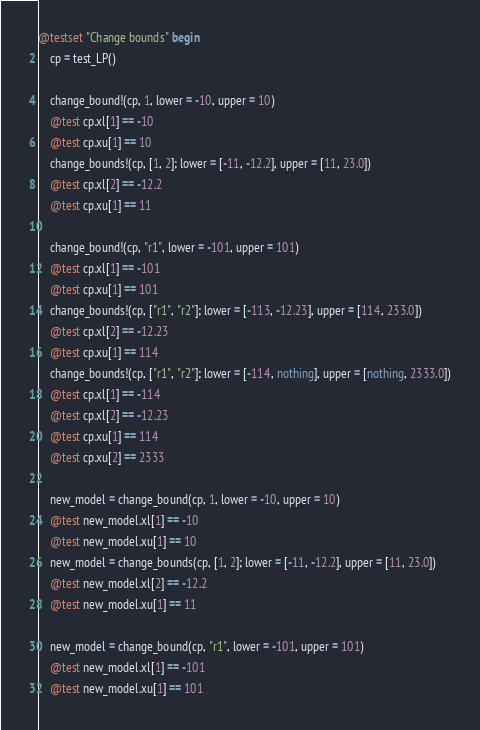Convert code to text. <code><loc_0><loc_0><loc_500><loc_500><_Julia_>@testset "Change bounds" begin
    cp = test_LP()

    change_bound!(cp, 1, lower = -10, upper = 10)
    @test cp.xl[1] == -10
    @test cp.xu[1] == 10
    change_bounds!(cp, [1, 2]; lower = [-11, -12.2], upper = [11, 23.0])
    @test cp.xl[2] == -12.2
    @test cp.xu[1] == 11

    change_bound!(cp, "r1", lower = -101, upper = 101)
    @test cp.xl[1] == -101
    @test cp.xu[1] == 101
    change_bounds!(cp, ["r1", "r2"]; lower = [-113, -12.23], upper = [114, 233.0])
    @test cp.xl[2] == -12.23
    @test cp.xu[1] == 114
    change_bounds!(cp, ["r1", "r2"]; lower = [-114, nothing], upper = [nothing, 2333.0])
    @test cp.xl[1] == -114
    @test cp.xl[2] == -12.23
    @test cp.xu[1] == 114
    @test cp.xu[2] == 2333

    new_model = change_bound(cp, 1, lower = -10, upper = 10)
    @test new_model.xl[1] == -10
    @test new_model.xu[1] == 10
    new_model = change_bounds(cp, [1, 2]; lower = [-11, -12.2], upper = [11, 23.0])
    @test new_model.xl[2] == -12.2
    @test new_model.xu[1] == 11

    new_model = change_bound(cp, "r1", lower = -101, upper = 101)
    @test new_model.xl[1] == -101
    @test new_model.xu[1] == 101</code> 